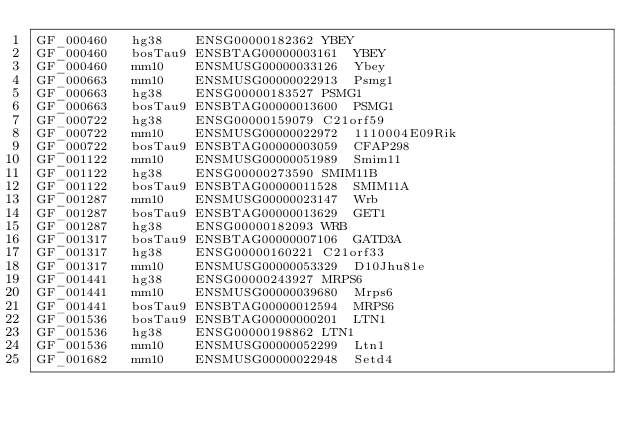Convert code to text. <code><loc_0><loc_0><loc_500><loc_500><_SQL_>GF_000460	hg38	ENSG00000182362	YBEY
GF_000460	bosTau9	ENSBTAG00000003161	YBEY
GF_000460	mm10	ENSMUSG00000033126	Ybey
GF_000663	mm10	ENSMUSG00000022913	Psmg1
GF_000663	hg38	ENSG00000183527	PSMG1
GF_000663	bosTau9	ENSBTAG00000013600	PSMG1
GF_000722	hg38	ENSG00000159079	C21orf59
GF_000722	mm10	ENSMUSG00000022972	1110004E09Rik
GF_000722	bosTau9	ENSBTAG00000003059	CFAP298
GF_001122	mm10	ENSMUSG00000051989	Smim11
GF_001122	hg38	ENSG00000273590	SMIM11B
GF_001122	bosTau9	ENSBTAG00000011528	SMIM11A
GF_001287	mm10	ENSMUSG00000023147	Wrb
GF_001287	bosTau9	ENSBTAG00000013629	GET1
GF_001287	hg38	ENSG00000182093	WRB
GF_001317	bosTau9	ENSBTAG00000007106	GATD3A
GF_001317	hg38	ENSG00000160221	C21orf33
GF_001317	mm10	ENSMUSG00000053329	D10Jhu81e
GF_001441	hg38	ENSG00000243927	MRPS6
GF_001441	mm10	ENSMUSG00000039680	Mrps6
GF_001441	bosTau9	ENSBTAG00000012594	MRPS6
GF_001536	bosTau9	ENSBTAG00000000201	LTN1
GF_001536	hg38	ENSG00000198862	LTN1
GF_001536	mm10	ENSMUSG00000052299	Ltn1
GF_001682	mm10	ENSMUSG00000022948	Setd4</code> 